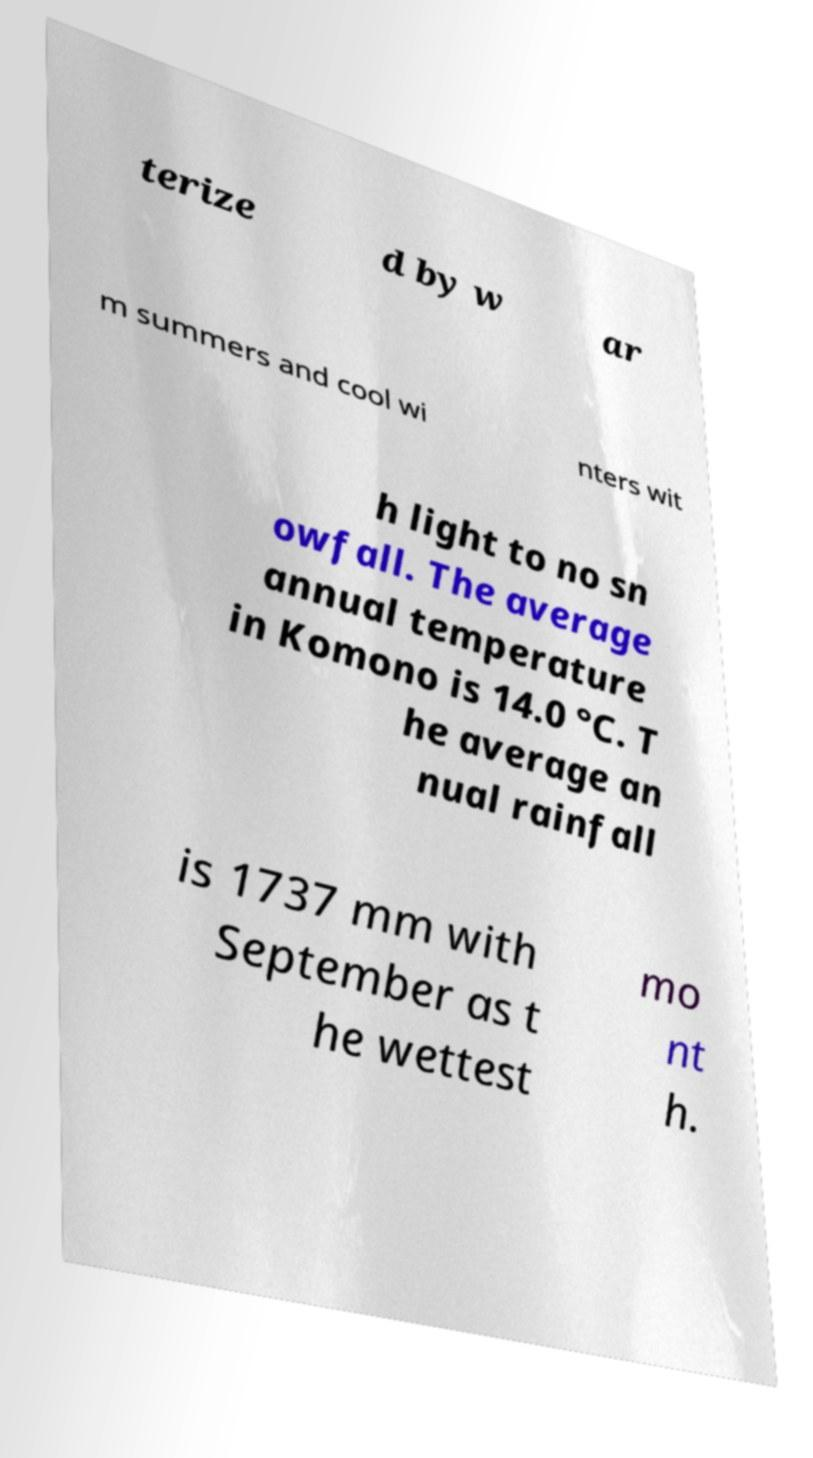Could you assist in decoding the text presented in this image and type it out clearly? terize d by w ar m summers and cool wi nters wit h light to no sn owfall. The average annual temperature in Komono is 14.0 °C. T he average an nual rainfall is 1737 mm with September as t he wettest mo nt h. 